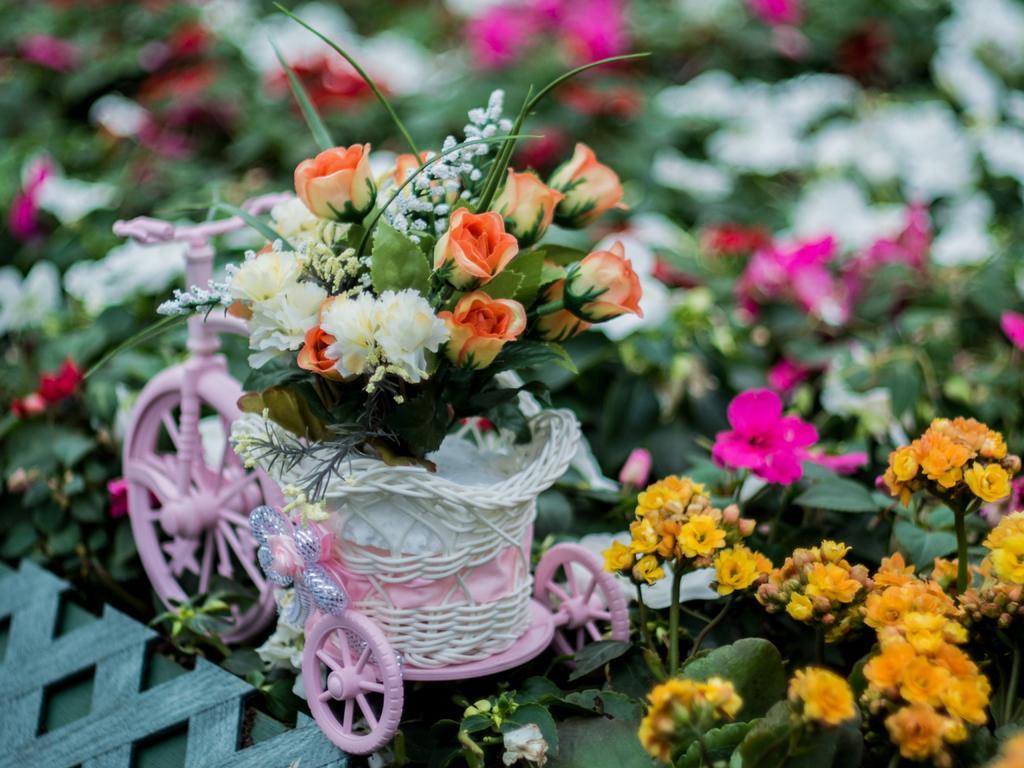How would you summarize this image in a sentence or two? There are some flowers in the bottom right of the image. There is a cycle in the middle of the image contains roses. 